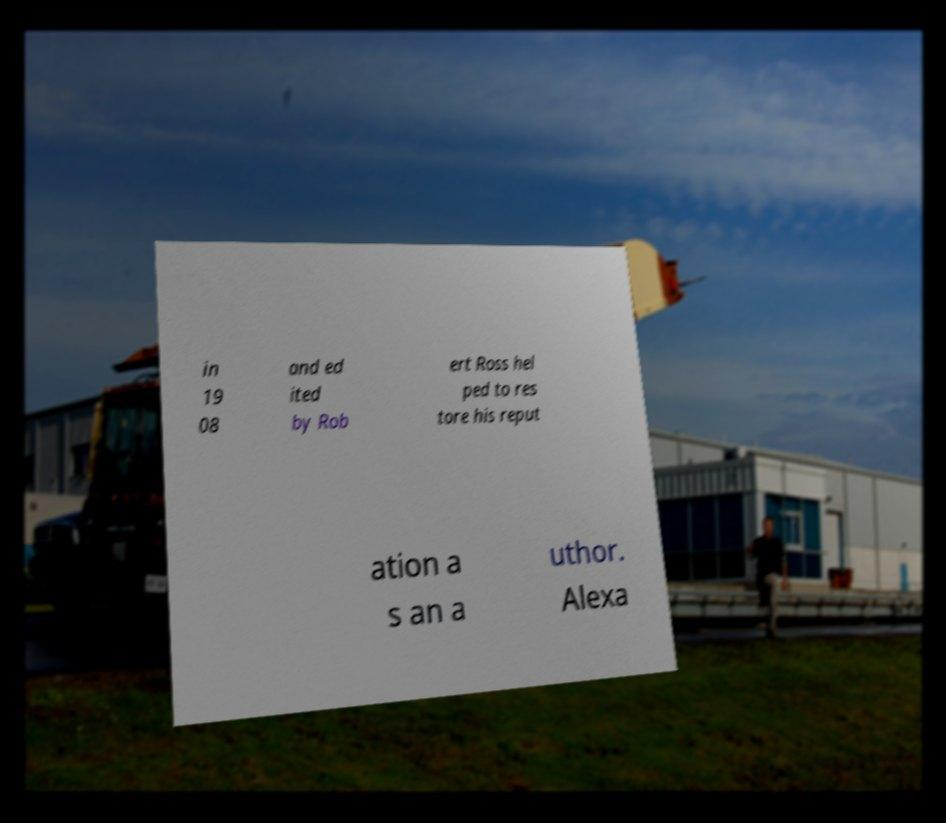I need the written content from this picture converted into text. Can you do that? in 19 08 and ed ited by Rob ert Ross hel ped to res tore his reput ation a s an a uthor. Alexa 